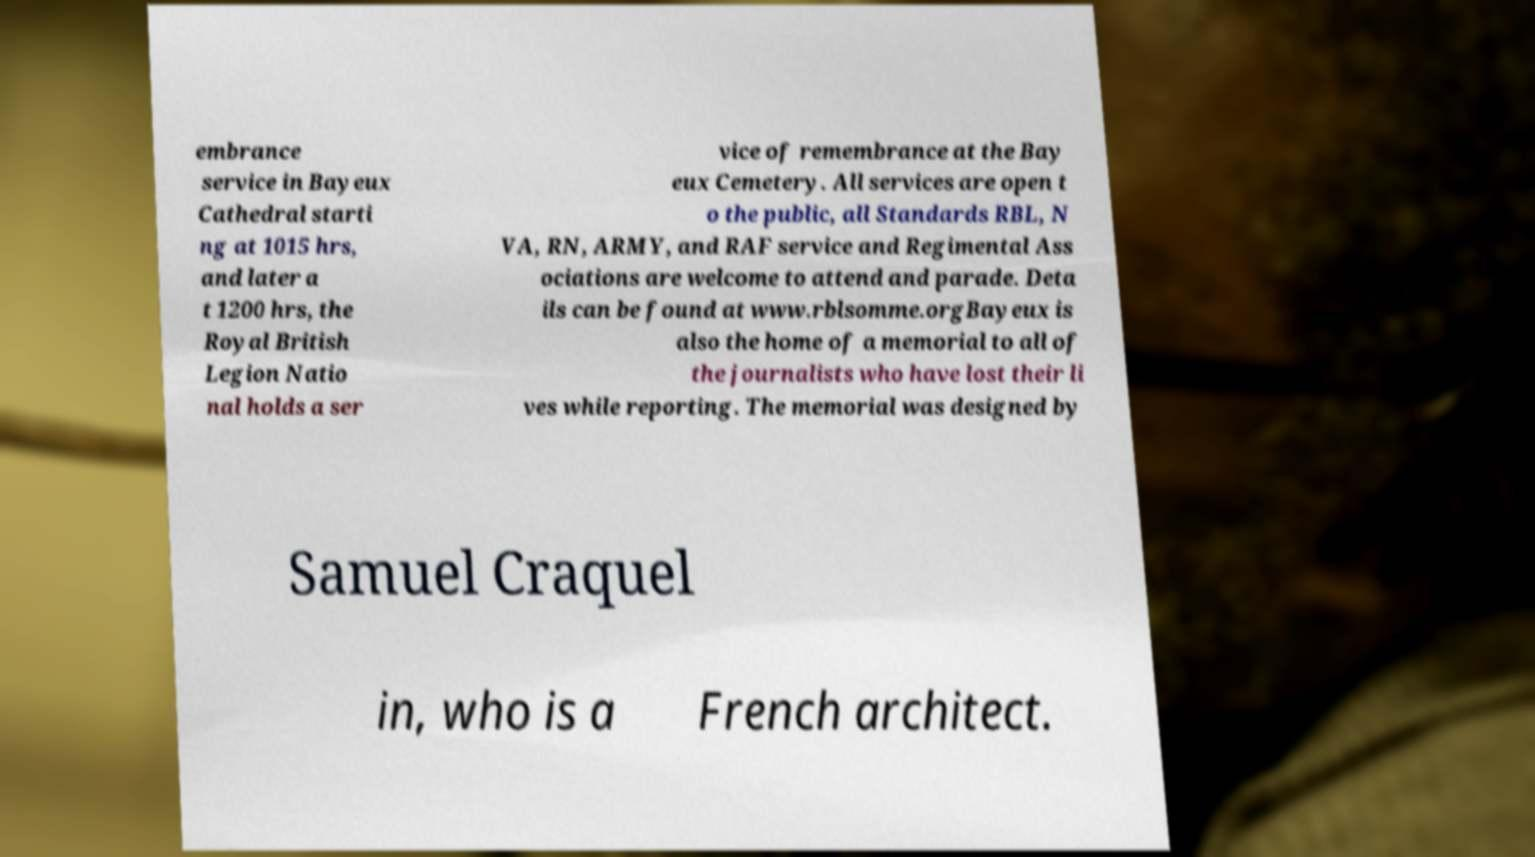For documentation purposes, I need the text within this image transcribed. Could you provide that? embrance service in Bayeux Cathedral starti ng at 1015 hrs, and later a t 1200 hrs, the Royal British Legion Natio nal holds a ser vice of remembrance at the Bay eux Cemetery. All services are open t o the public, all Standards RBL, N VA, RN, ARMY, and RAF service and Regimental Ass ociations are welcome to attend and parade. Deta ils can be found at www.rblsomme.orgBayeux is also the home of a memorial to all of the journalists who have lost their li ves while reporting. The memorial was designed by Samuel Craquel in, who is a French architect. 